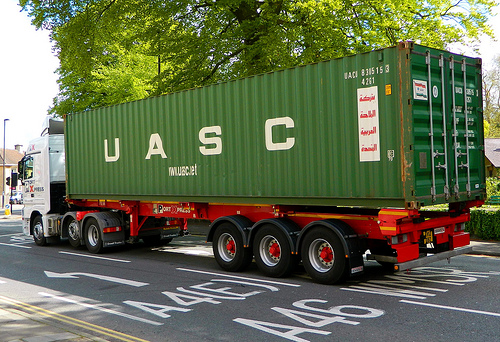Is this a bus or a truck? This vehicle is a truck. 